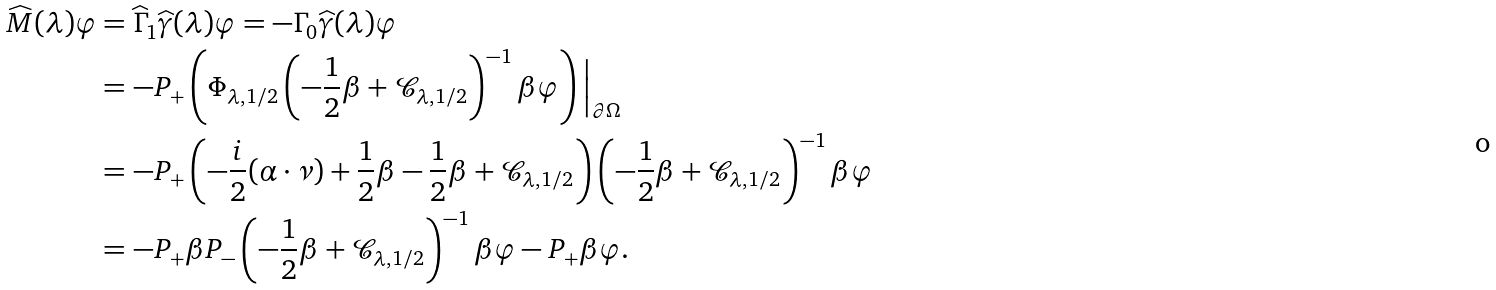<formula> <loc_0><loc_0><loc_500><loc_500>\widehat { M } ( \lambda ) \varphi & = \widehat { \Gamma } _ { 1 } \widehat { \gamma } ( \lambda ) \varphi = - \Gamma _ { 0 } \widehat { \gamma } ( \lambda ) \varphi \\ & = - P _ { + } \left ( \Phi _ { \lambda , 1 / 2 } \left ( - \frac { 1 } { 2 } \beta + \mathcal { C } _ { \lambda , 1 / 2 } \right ) ^ { - 1 } \beta \varphi \right ) \Big | _ { \partial \Omega } \\ & = - P _ { + } \left ( - \frac { i } { 2 } ( \alpha \cdot \nu ) + \frac { 1 } { 2 } \beta - \frac { 1 } { 2 } \beta + \mathcal { C } _ { \lambda , 1 / 2 } \right ) \left ( - \frac { 1 } { 2 } \beta + \mathcal { C } _ { \lambda , 1 / 2 } \right ) ^ { - 1 } \beta \varphi \\ & = - P _ { + } \beta P _ { - } \left ( - \frac { 1 } { 2 } \beta + \mathcal { C } _ { \lambda , 1 / 2 } \right ) ^ { - 1 } \beta \varphi - P _ { + } \beta \varphi .</formula> 